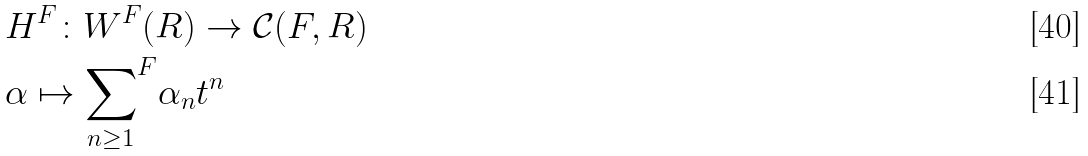Convert formula to latex. <formula><loc_0><loc_0><loc_500><loc_500>& H ^ { F } \colon W ^ { F } ( R ) \to \mathcal { C } ( F , R ) \\ & \alpha \mapsto { \sum _ { n \geq 1 } } ^ { F } \alpha _ { n } t ^ { n }</formula> 